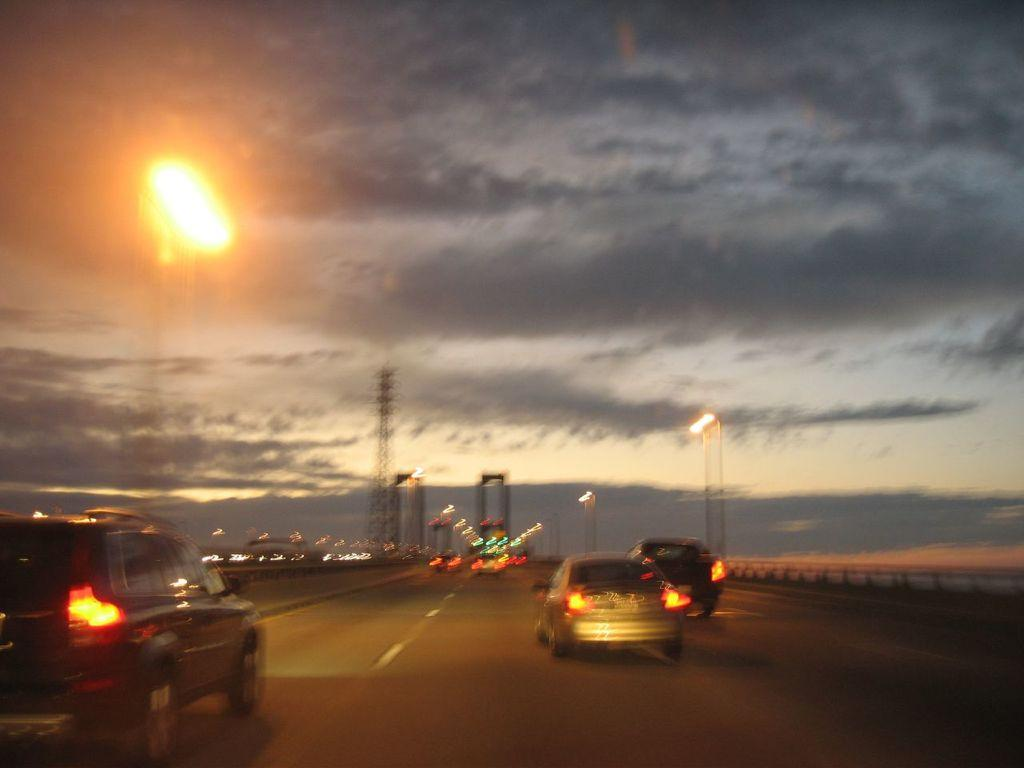What type of vehicles can be seen on the road in the image? There are motor vehicles on the road in the image. What structures are present in the image that are related to electricity? Electric towers and electric lights are visible in the image. What type of poles are in the image? Street poles are in the image. What type of lights are present in the image? Street lights are present in the image. What can be seen in the sky in the image? The sky is visible in the image, and clouds are present in the sky. Where is the tramp located in the image? There is no tramp present in the image. How many members of the family can be seen in the image? There is no family present in the image. 